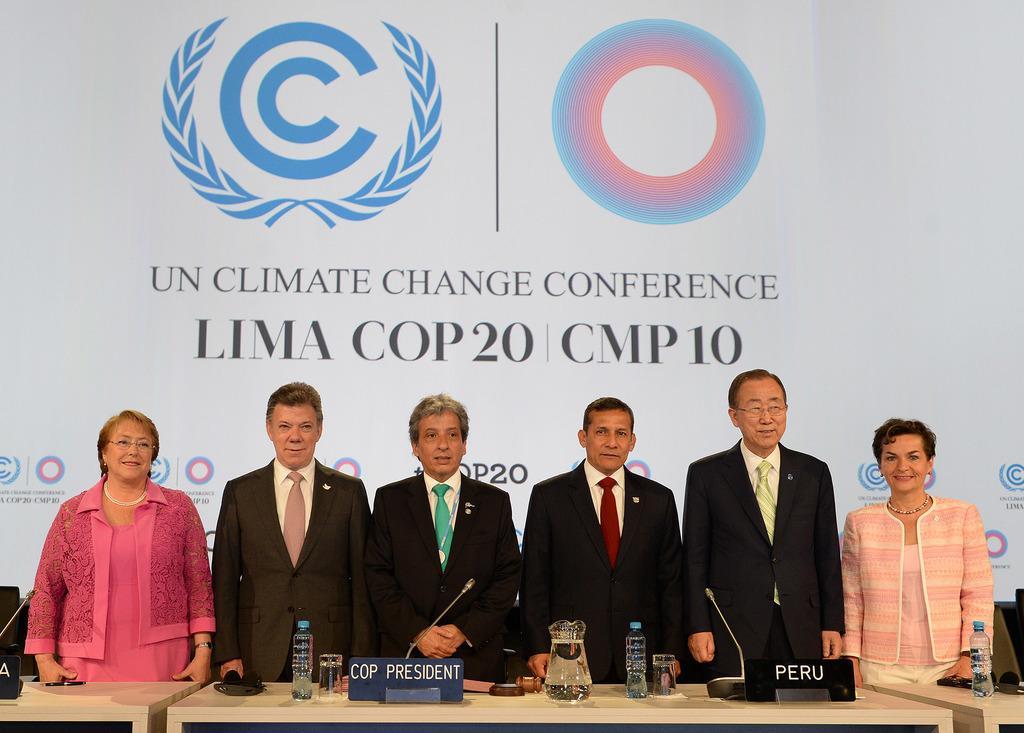Can you describe this image briefly? In this image I can see number of people are standing, I can see most of them are wearing formal dress and few of them are wearing jackets. I can also see few tables and on these tables I can see few boards, few bottles, a jar, a glass and on these boards I can see something is written. In the background I can see white color thing and on it I can see few logos and I can see something is written on it. 